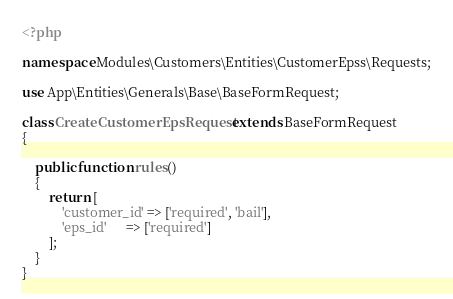<code> <loc_0><loc_0><loc_500><loc_500><_PHP_><?php

namespace Modules\Customers\Entities\CustomerEpss\Requests;

use App\Entities\Generals\Base\BaseFormRequest;

class CreateCustomerEpsRequest extends BaseFormRequest
{

    public function rules()
    {
        return [
            'customer_id' => ['required', 'bail'],
            'eps_id'      => ['required']
        ];
    }
}
</code> 